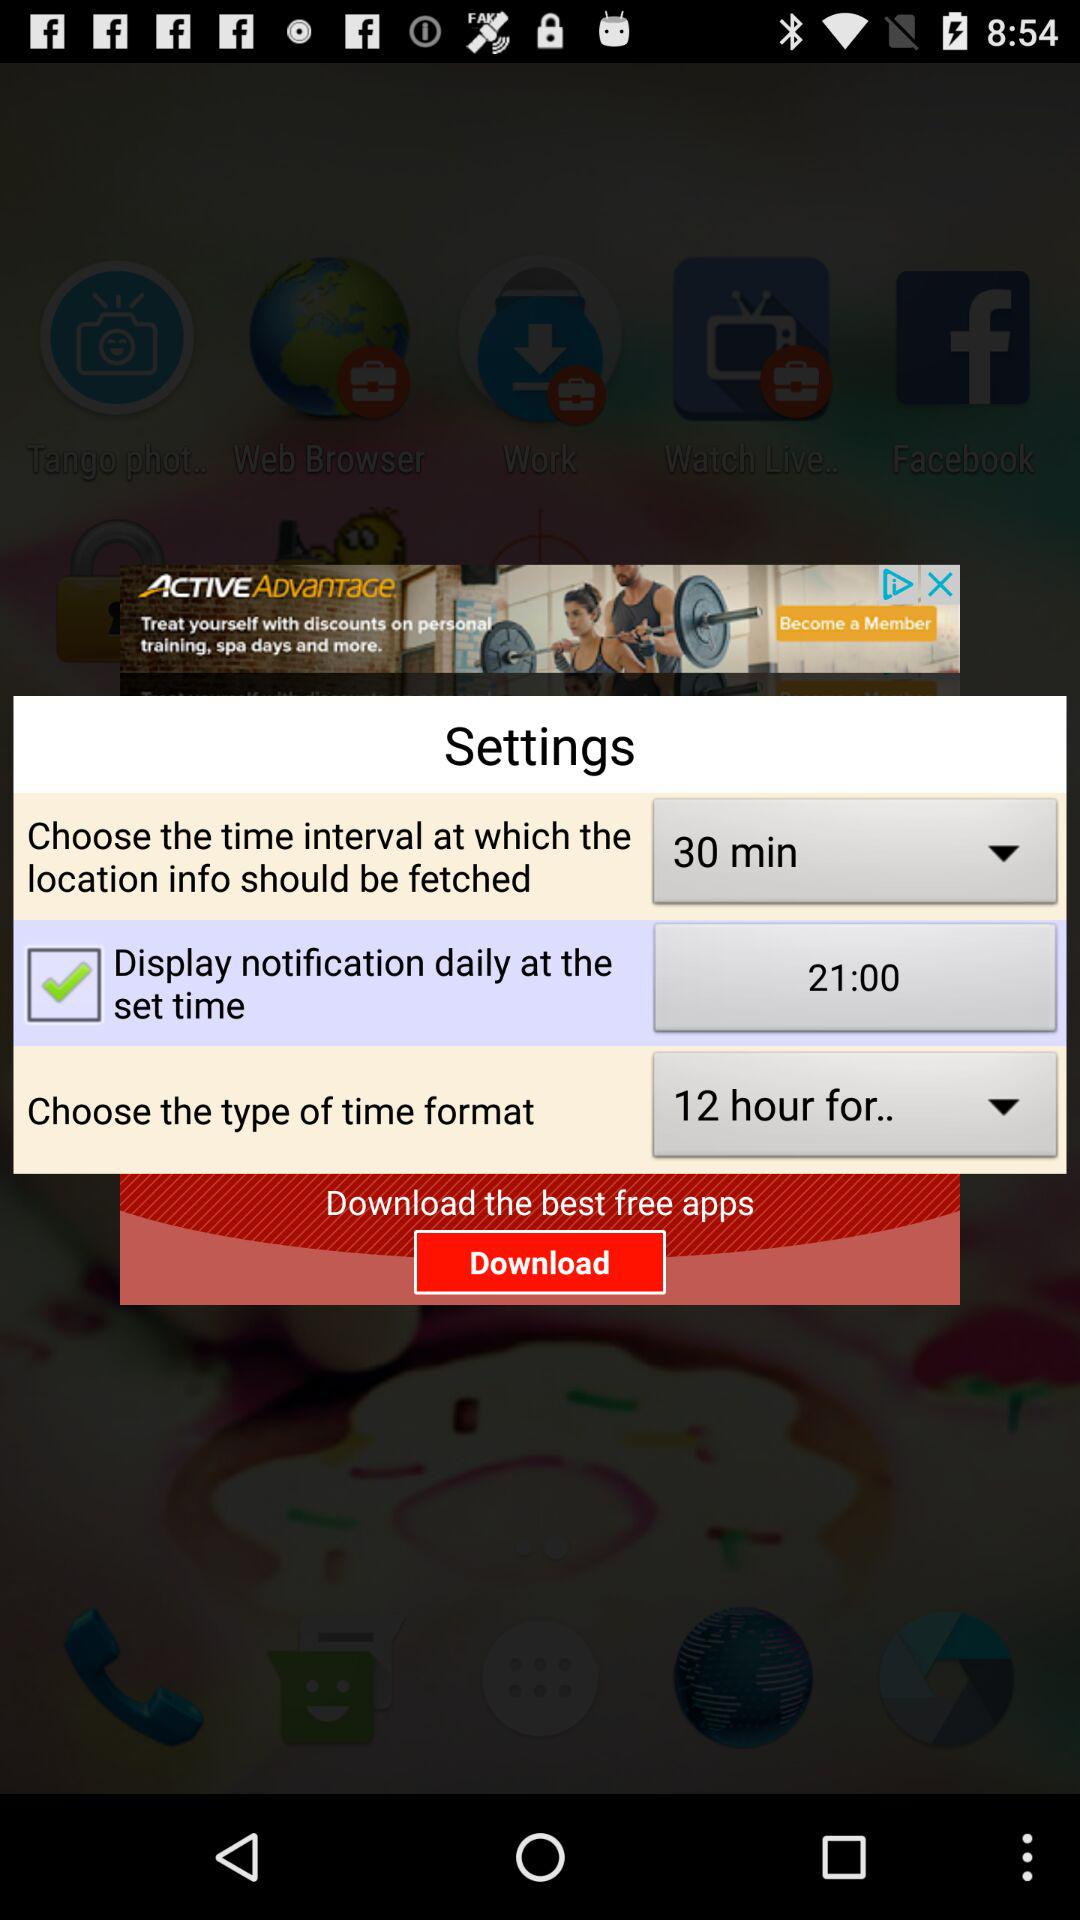What is the chosen time format? The chosen time format is 12 hours. 